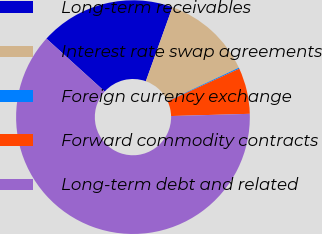<chart> <loc_0><loc_0><loc_500><loc_500><pie_chart><fcel>Long-term receivables<fcel>Interest rate swap agreements<fcel>Foreign currency exchange<fcel>Forward commodity contracts<fcel>Long-term debt and related<nl><fcel>18.76%<fcel>12.56%<fcel>0.15%<fcel>6.35%<fcel>62.18%<nl></chart> 